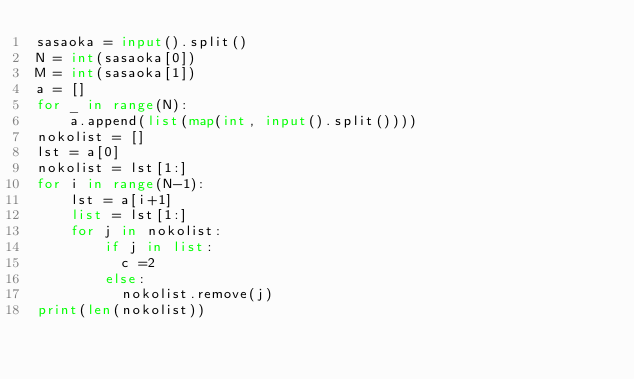<code> <loc_0><loc_0><loc_500><loc_500><_Python_>sasaoka = input().split()
N = int(sasaoka[0])
M = int(sasaoka[1])
a = []
for _ in range(N):
    a.append(list(map(int, input().split())))
nokolist = []
lst = a[0]
nokolist = lst[1:]
for i in range(N-1):
    lst = a[i+1]
    list = lst[1:]
    for j in nokolist:
        if j in list:
          c =2
        else:
          nokolist.remove(j)
print(len(nokolist))</code> 